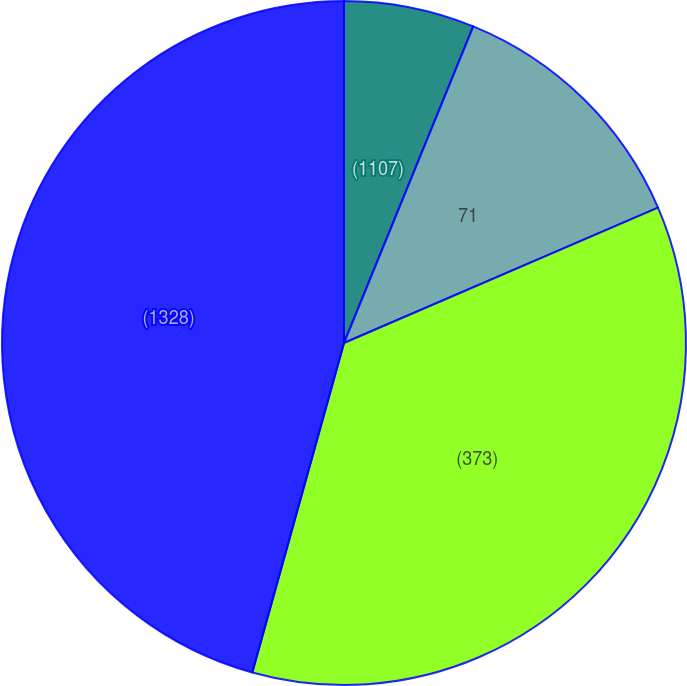<chart> <loc_0><loc_0><loc_500><loc_500><pie_chart><fcel>(1107)<fcel>71<fcel>(373)<fcel>(1328)<nl><fcel>6.17%<fcel>12.35%<fcel>35.8%<fcel>45.68%<nl></chart> 